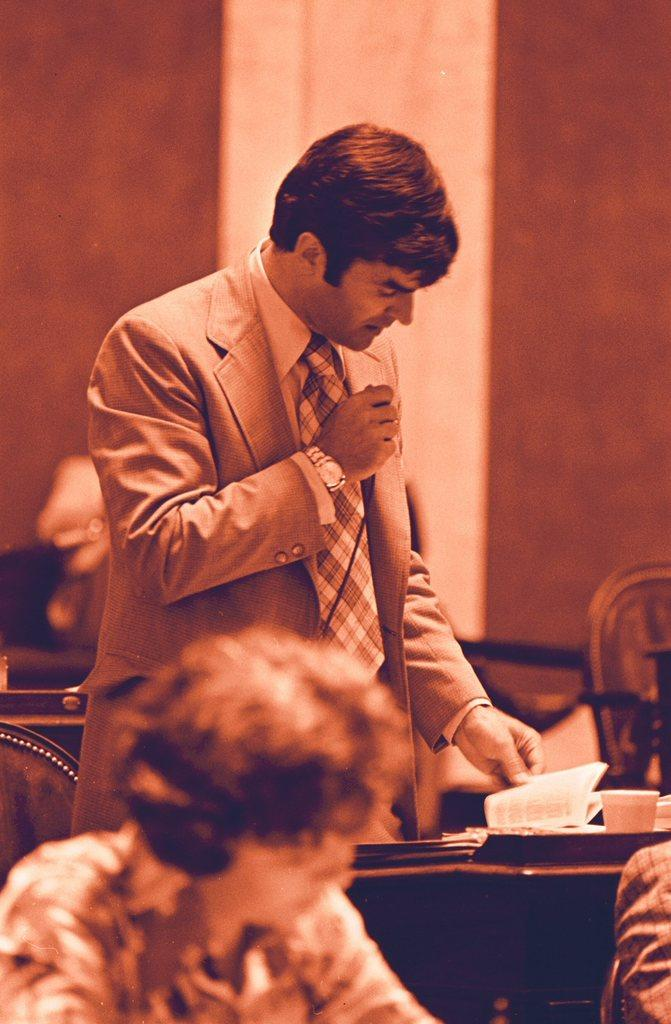What is the man in the image doing? The man is standing in the image and holding a book. What else can be seen in the image besides the man? There is a cup and a woman on the left side of the image. What is the background of the image? There is a wall in the background of the image. What type of lettuce is growing on the wall in the image? There is no lettuce present in the image; the background only features a wall. 